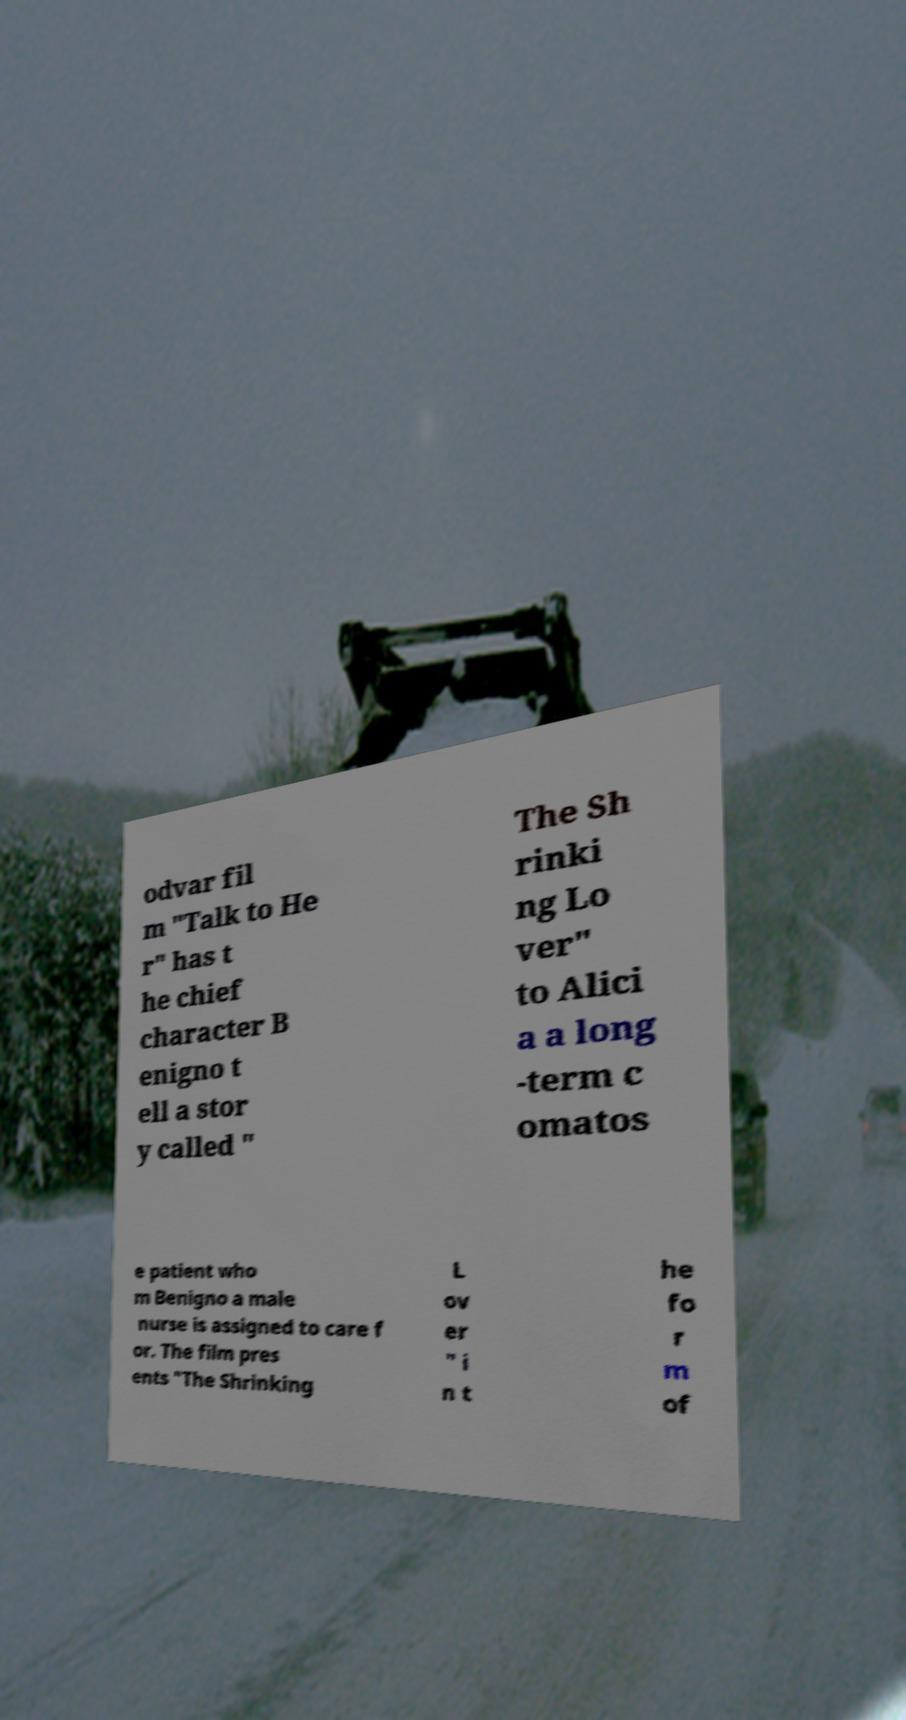There's text embedded in this image that I need extracted. Can you transcribe it verbatim? odvar fil m "Talk to He r" has t he chief character B enigno t ell a stor y called " The Sh rinki ng Lo ver" to Alici a a long -term c omatos e patient who m Benigno a male nurse is assigned to care f or. The film pres ents "The Shrinking L ov er " i n t he fo r m of 